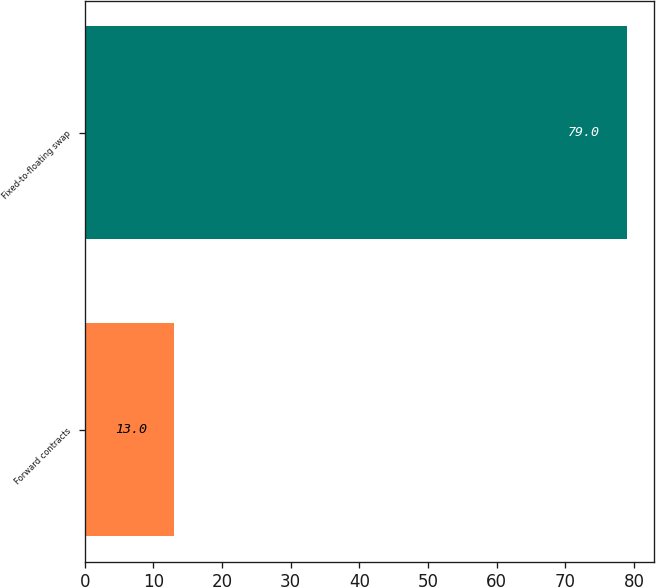Convert chart. <chart><loc_0><loc_0><loc_500><loc_500><bar_chart><fcel>Forward contracts<fcel>Fixed-to-floating swap<nl><fcel>13<fcel>79<nl></chart> 